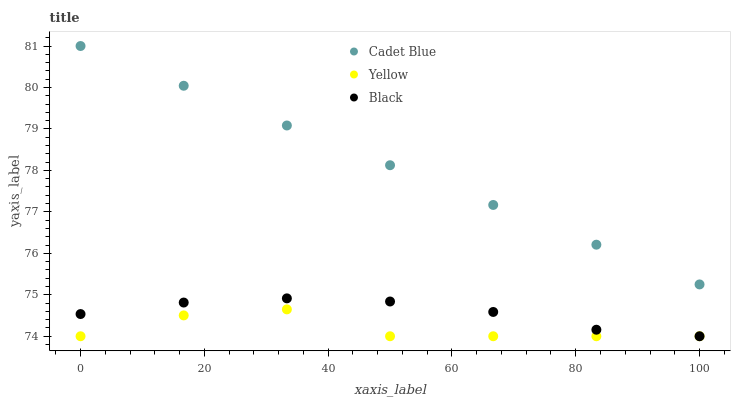Does Yellow have the minimum area under the curve?
Answer yes or no. Yes. Does Cadet Blue have the maximum area under the curve?
Answer yes or no. Yes. Does Black have the minimum area under the curve?
Answer yes or no. No. Does Black have the maximum area under the curve?
Answer yes or no. No. Is Cadet Blue the smoothest?
Answer yes or no. Yes. Is Yellow the roughest?
Answer yes or no. Yes. Is Black the smoothest?
Answer yes or no. No. Is Black the roughest?
Answer yes or no. No. Does Black have the lowest value?
Answer yes or no. Yes. Does Cadet Blue have the highest value?
Answer yes or no. Yes. Does Black have the highest value?
Answer yes or no. No. Is Black less than Cadet Blue?
Answer yes or no. Yes. Is Cadet Blue greater than Yellow?
Answer yes or no. Yes. Does Yellow intersect Black?
Answer yes or no. Yes. Is Yellow less than Black?
Answer yes or no. No. Is Yellow greater than Black?
Answer yes or no. No. Does Black intersect Cadet Blue?
Answer yes or no. No. 